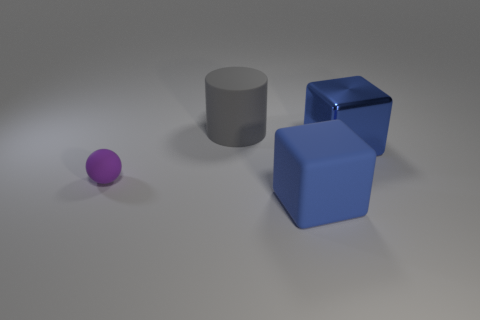There is a object that is on the right side of the blue cube in front of the small sphere; are there any matte spheres that are to the left of it?
Make the answer very short. Yes. How many metallic objects are small brown cylinders or small purple spheres?
Provide a short and direct response. 0. What number of other objects are there of the same shape as the large gray object?
Make the answer very short. 0. Is the number of large yellow cylinders greater than the number of big blue shiny blocks?
Provide a succinct answer. No. What is the size of the blue object that is in front of the purple matte object that is behind the block in front of the big blue metallic cube?
Give a very brief answer. Large. What size is the blue cube that is behind the large matte cube?
Provide a succinct answer. Large. How many things are either tiny objects or large blue cubes that are left of the big blue shiny block?
Offer a very short reply. 2. What number of other objects are the same size as the ball?
Offer a very short reply. 0. What material is the other blue object that is the same shape as the big blue matte thing?
Your answer should be very brief. Metal. Are there more big gray rubber cylinders that are behind the cylinder than small gray cylinders?
Your answer should be compact. No. 